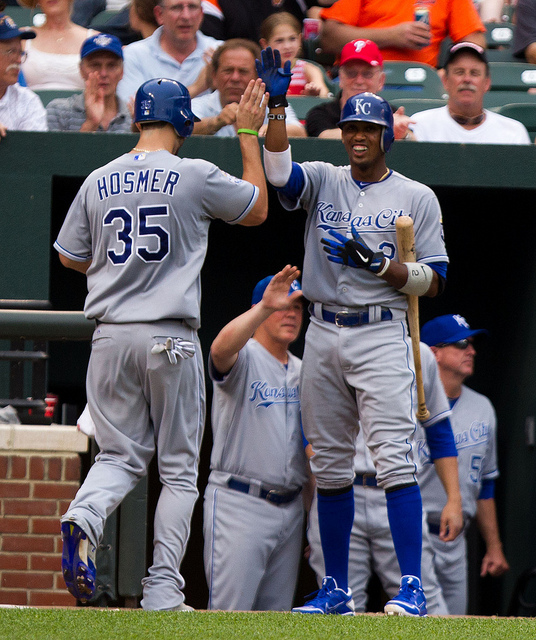<image>What brand are the baseball player's shoes? I am not sure about the brand of the baseball player's shoes. It could be 'new balance', 'nike' or 'puma'. What brand are the baseball player's shoes? I am not sure the brand of the baseball player's shoes. It can be either 'new balance', 'nike', 'puma' or other. 